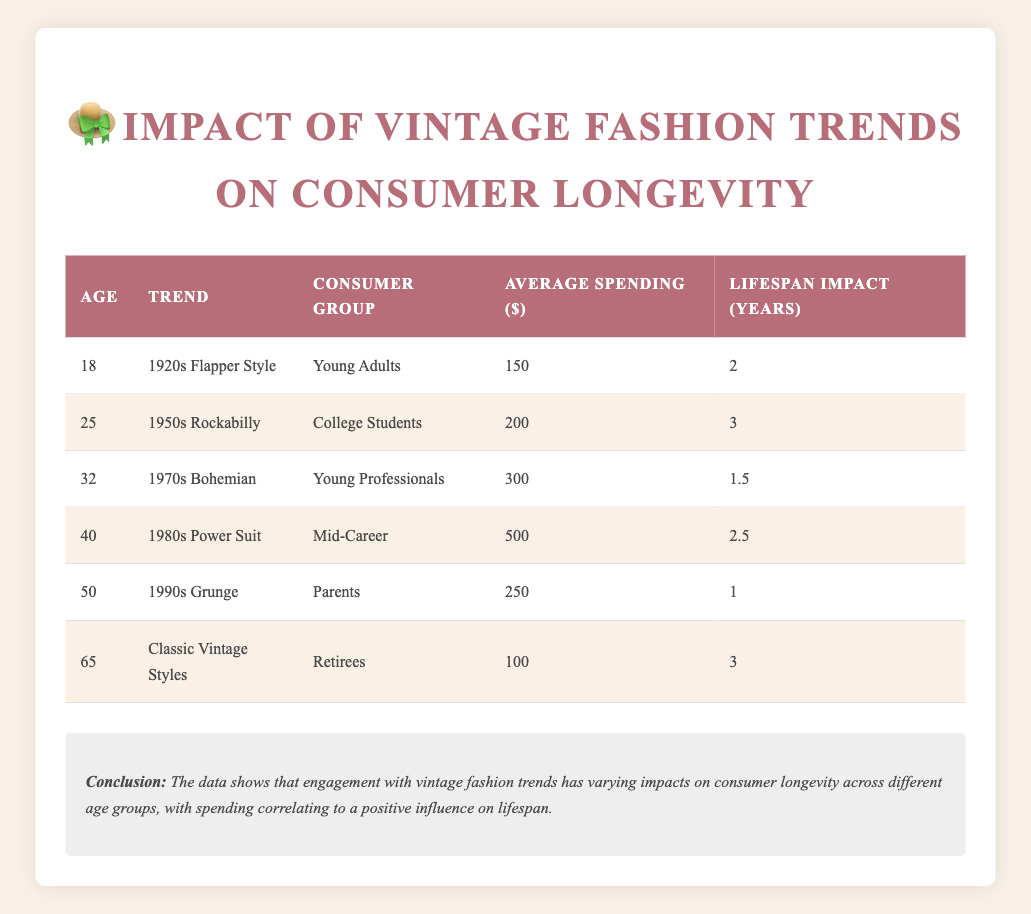What is the average spending of consumers aged 25? The table shows that the average spending for consumers aged 25, who are college students reflecting the 1950s Rockabilly trend, is $200
Answer: 200 Which vintage fashion trend has the highest lifespan impact? The maximum value in the Lifespan Impact column is 3 years, which corresponds to both the 1950s Rockabilly trend (age 25) and the Classic Vintage Styles (age 65)
Answer: 1950s Rockabilly and Classic Vintage Styles Is the average spending for the 1980s Power Suit higher than for the 1990s Grunge? The average spending for the 1980s Power Suit is $500, while for the 1990s Grunge it is $250. Since $500 is greater than $250, the statement is true
Answer: Yes What is the total lifespan impact for the trends represented for age groups 40 and 50? For age 40, the lifespan impact is 2.5 years (1980s Power Suit) and for age 50, it is 1 year (1990s Grunge). Adding these gives 2.5 + 1 = 3.5 years
Answer: 3.5 At which age does the trend "1970s Bohemian" appear and what is its lifespan impact? The trend "1970s Bohemian" appears at age 32 and has a lifespan impact of 1.5 years
Answer: Age 32, Lifespan Impact 1.5 What is the lifespan impact difference between the "1950s Rockabilly" and "1980s Power Suit"? The lifespan impact for "1950s Rockabilly" is 3 years and for "1980s Power Suit" is 2.5 years. The difference is 3 - 2.5 = 0.5 years
Answer: 0.5 Is it true that the lifespan impact related to "Classic Vintage Styles" is 2 years? The table shows that the lifespan impact for "Classic Vintage Styles" is 3 years, not 2. Therefore, the statement is false
Answer: No How much more do young professionals spend on average compared to young adults? The average spending for young professionals (32 years old, 1970s Bohemian) is $300, while young adults (18 years old, 1920s Flapper Style) spend $150. The difference is 300 - 150 = 150
Answer: 150 Which consumer group has the lowest average spending? The consumer group "Retirees" spend the least with an average of $100, based on the values in the Average Spending column
Answer: Retirees 